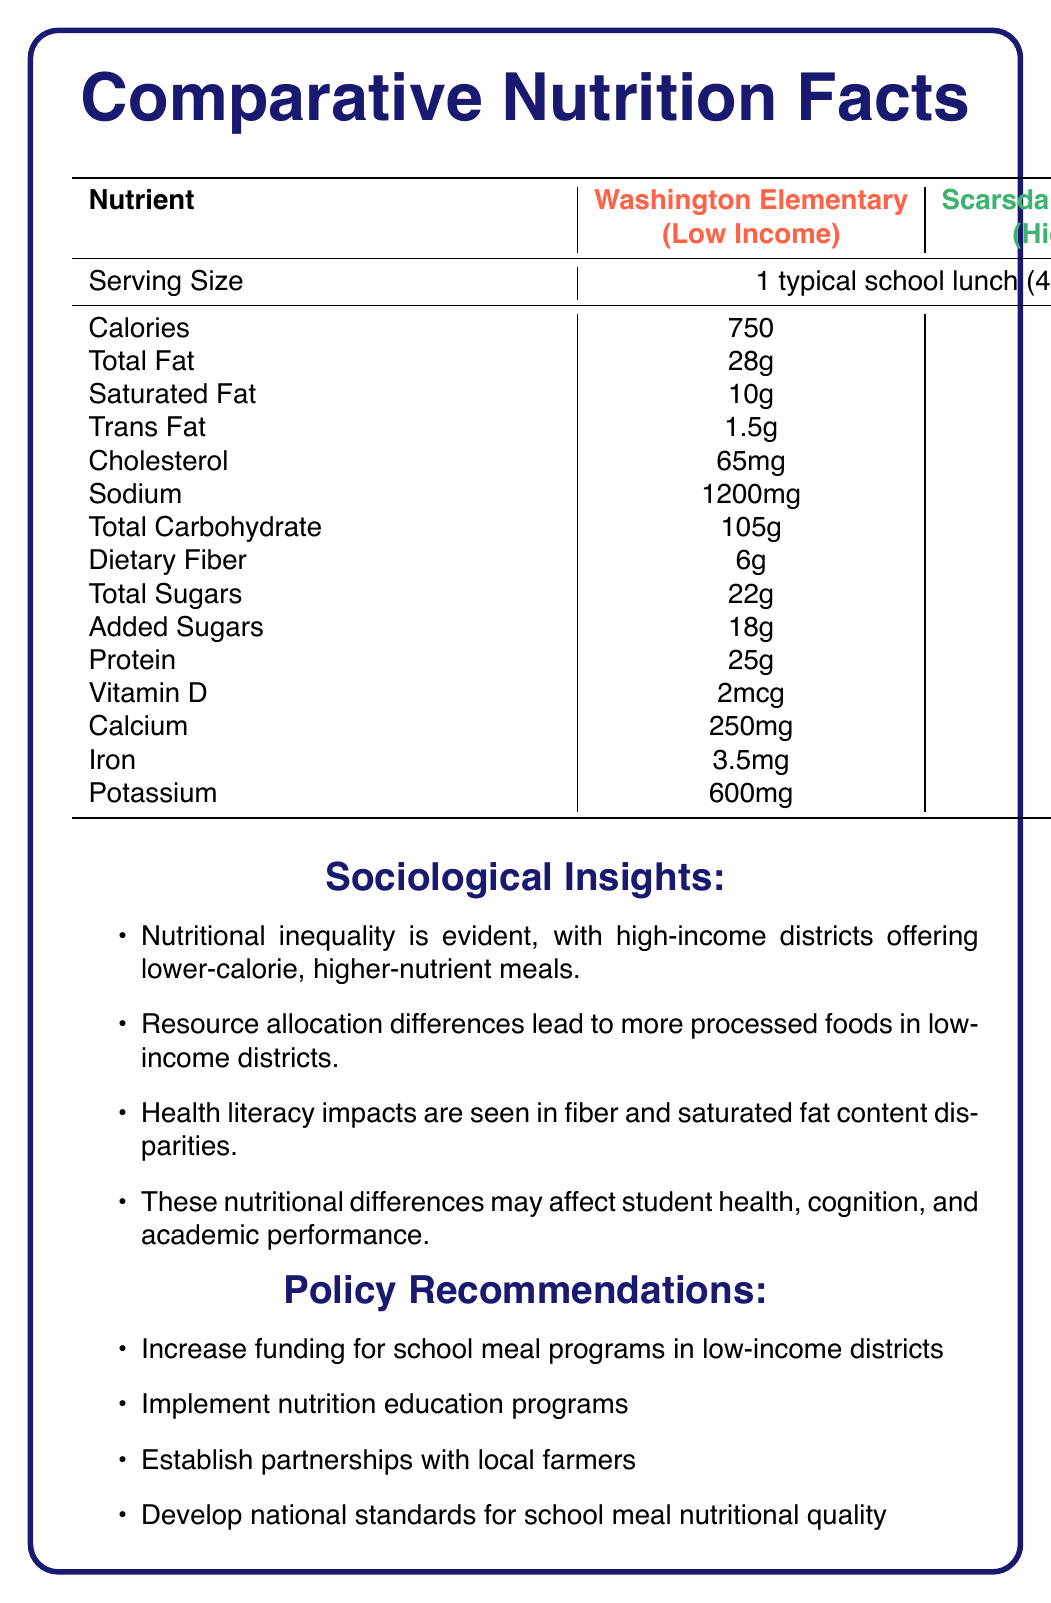What is the total calorie count for a typical school lunch in a low-income district? The document lists the calorie count for Washington Elementary (a low-income district) as 750 calories.
Answer: 750 What school is referenced as the high-income district? The high-income district is identified as Scarsdale Middle School in the document.
Answer: Scarsdale Middle School How much protein is in the lunch provided by high-income district schools? The document states that Scarsdale Middle School’s lunch contains 30 grams of protein.
Answer: 30g Which nutrient has the highest difference in quantity between low-income and high-income district lunches? The sodium content is 1200mg in the low-income district and 800mg in the high-income district, showing a difference of 400mg, which is the highest difference among all listed nutrients.
Answer: Sodium How much more dietary fiber does the lunch from the high-income district contain compared to the low-income district lunch? The document shows that the dietary fiber in Scarsdale Middle School is 10g, while it is 6g in Washington Elementary, making a difference of 4g.
Answer: 4g Which district has higher levels of saturated fat in their school lunches? A. Washington Elementary B. Scarsdale Middle School Washington Elementary (low-income) has 10g of saturated fat, which is higher than Scarsdale Middle School’s (high-income) 6g.
Answer: A. Washington Elementary Which of the following is NOT a policy recommendation mentioned in the document? A. Increase funding for school meal programs in low-income districts B. Offer free gym memberships to students C. Establish partnerships with local farmers D. Develop national standards for school meal nutritional quality The document lists increasing funding, establishing partnerships with farmers, and developing nutritional standards, but does not mention offering free gym memberships.
Answer: B. Offer free gym memberships to students Is there a significant difference in the added sugars content between low-income and high-income district lunches? The document shows that added sugars are 18g in the low-income district and 8g in the high-income district, which is a significant difference.
Answer: Yes Summarize the main insights presented in the document. The document provides a detailed comparison of school lunch nutrition between two districts, discusses the implications of these disparities, and suggests policies to mitigate them.
Answer: The document compares the nutritional content of school lunches between low-income and high-income districts, highlighting disparities in calorie count, nutrient content, and potential health implications. It also provides sociological insights and policy recommendations to address these nutritional inequalities. What is the percentage of daily value for Vitamin D in the high-income district's lunches? The document lists the amount of Vitamin D but does not provide the percentage of daily value.
Answer: Cannot be determined What health concern is associated with higher sodium levels in the low-income district? The document notes that the higher sodium levels in low-income districts highlight reliance on processed foods, often due to budget constraints and limited access to fresh ingredients.
Answer: Processed food reliance Which district offers a lunch with lower cholesterol content? A. Washington Elementary B. Scarsdale Middle School The cholesterol content in Scarsdale Middle School’s lunch is 45mg, while it is 65mg in Washington Elementary’s lunch.
Answer: B. Scarsdale Middle School Which nutrient appears to be in equal or nearly equal amounts in both district lunches? Both Washington Elementary and Scarsdale Middle School's lunches contain potassium, with 600mg and 800mg respectively, making it a relatively close amount compared to other nutrients listed.
Answer: Potassium 